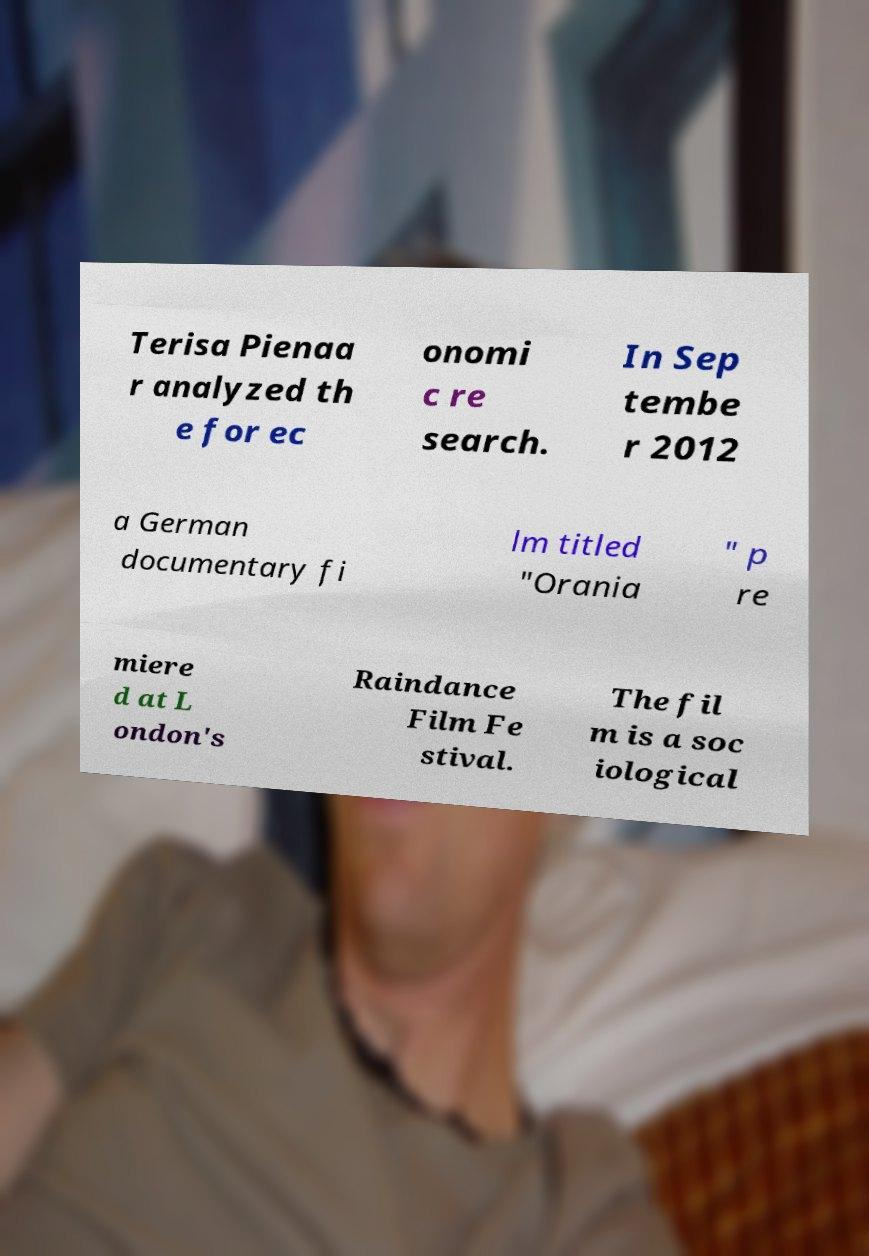Please read and relay the text visible in this image. What does it say? Terisa Pienaa r analyzed th e for ec onomi c re search. In Sep tembe r 2012 a German documentary fi lm titled "Orania " p re miere d at L ondon's Raindance Film Fe stival. The fil m is a soc iological 